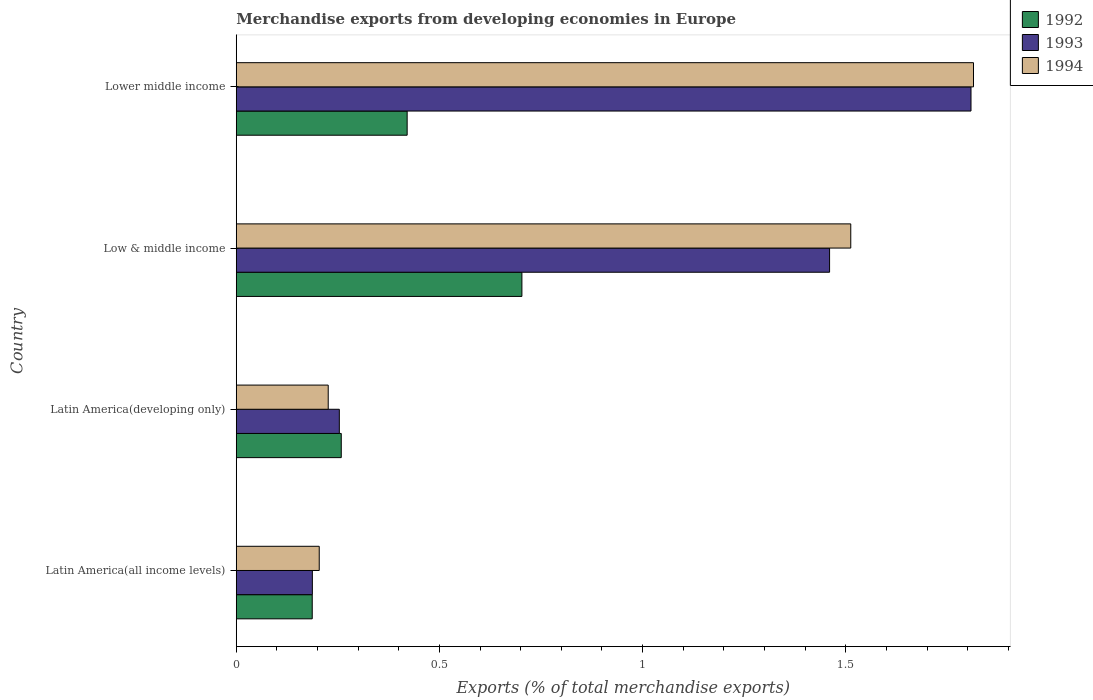How many different coloured bars are there?
Your response must be concise. 3. Are the number of bars per tick equal to the number of legend labels?
Offer a very short reply. Yes. How many bars are there on the 4th tick from the top?
Offer a terse response. 3. How many bars are there on the 2nd tick from the bottom?
Your response must be concise. 3. What is the label of the 4th group of bars from the top?
Your answer should be compact. Latin America(all income levels). What is the percentage of total merchandise exports in 1994 in Low & middle income?
Give a very brief answer. 1.51. Across all countries, what is the maximum percentage of total merchandise exports in 1993?
Your response must be concise. 1.81. Across all countries, what is the minimum percentage of total merchandise exports in 1994?
Give a very brief answer. 0.2. In which country was the percentage of total merchandise exports in 1994 maximum?
Offer a terse response. Lower middle income. In which country was the percentage of total merchandise exports in 1994 minimum?
Your answer should be very brief. Latin America(all income levels). What is the total percentage of total merchandise exports in 1994 in the graph?
Give a very brief answer. 3.76. What is the difference between the percentage of total merchandise exports in 1994 in Latin America(all income levels) and that in Low & middle income?
Provide a succinct answer. -1.31. What is the difference between the percentage of total merchandise exports in 1993 in Lower middle income and the percentage of total merchandise exports in 1994 in Latin America(all income levels)?
Give a very brief answer. 1.6. What is the average percentage of total merchandise exports in 1992 per country?
Keep it short and to the point. 0.39. What is the difference between the percentage of total merchandise exports in 1993 and percentage of total merchandise exports in 1994 in Lower middle income?
Provide a short and direct response. -0.01. What is the ratio of the percentage of total merchandise exports in 1992 in Low & middle income to that in Lower middle income?
Provide a succinct answer. 1.67. Is the difference between the percentage of total merchandise exports in 1993 in Low & middle income and Lower middle income greater than the difference between the percentage of total merchandise exports in 1994 in Low & middle income and Lower middle income?
Make the answer very short. No. What is the difference between the highest and the second highest percentage of total merchandise exports in 1994?
Make the answer very short. 0.3. What is the difference between the highest and the lowest percentage of total merchandise exports in 1993?
Give a very brief answer. 1.62. In how many countries, is the percentage of total merchandise exports in 1994 greater than the average percentage of total merchandise exports in 1994 taken over all countries?
Provide a short and direct response. 2. How many bars are there?
Give a very brief answer. 12. Are all the bars in the graph horizontal?
Provide a succinct answer. Yes. How many countries are there in the graph?
Offer a terse response. 4. Are the values on the major ticks of X-axis written in scientific E-notation?
Keep it short and to the point. No. Does the graph contain any zero values?
Ensure brevity in your answer.  No. How many legend labels are there?
Offer a very short reply. 3. What is the title of the graph?
Your answer should be compact. Merchandise exports from developing economies in Europe. What is the label or title of the X-axis?
Ensure brevity in your answer.  Exports (% of total merchandise exports). What is the label or title of the Y-axis?
Give a very brief answer. Country. What is the Exports (% of total merchandise exports) in 1992 in Latin America(all income levels)?
Offer a very short reply. 0.19. What is the Exports (% of total merchandise exports) in 1993 in Latin America(all income levels)?
Offer a very short reply. 0.19. What is the Exports (% of total merchandise exports) in 1994 in Latin America(all income levels)?
Make the answer very short. 0.2. What is the Exports (% of total merchandise exports) of 1992 in Latin America(developing only)?
Your answer should be compact. 0.26. What is the Exports (% of total merchandise exports) in 1993 in Latin America(developing only)?
Your answer should be very brief. 0.25. What is the Exports (% of total merchandise exports) in 1994 in Latin America(developing only)?
Provide a short and direct response. 0.23. What is the Exports (% of total merchandise exports) in 1992 in Low & middle income?
Your answer should be very brief. 0.7. What is the Exports (% of total merchandise exports) in 1993 in Low & middle income?
Offer a terse response. 1.46. What is the Exports (% of total merchandise exports) of 1994 in Low & middle income?
Offer a very short reply. 1.51. What is the Exports (% of total merchandise exports) of 1992 in Lower middle income?
Your answer should be compact. 0.42. What is the Exports (% of total merchandise exports) in 1993 in Lower middle income?
Your response must be concise. 1.81. What is the Exports (% of total merchandise exports) in 1994 in Lower middle income?
Make the answer very short. 1.81. Across all countries, what is the maximum Exports (% of total merchandise exports) of 1992?
Provide a short and direct response. 0.7. Across all countries, what is the maximum Exports (% of total merchandise exports) in 1993?
Offer a very short reply. 1.81. Across all countries, what is the maximum Exports (% of total merchandise exports) in 1994?
Your answer should be very brief. 1.81. Across all countries, what is the minimum Exports (% of total merchandise exports) in 1992?
Provide a short and direct response. 0.19. Across all countries, what is the minimum Exports (% of total merchandise exports) in 1993?
Offer a very short reply. 0.19. Across all countries, what is the minimum Exports (% of total merchandise exports) of 1994?
Give a very brief answer. 0.2. What is the total Exports (% of total merchandise exports) in 1992 in the graph?
Your response must be concise. 1.57. What is the total Exports (% of total merchandise exports) of 1993 in the graph?
Offer a very short reply. 3.71. What is the total Exports (% of total merchandise exports) of 1994 in the graph?
Offer a very short reply. 3.76. What is the difference between the Exports (% of total merchandise exports) in 1992 in Latin America(all income levels) and that in Latin America(developing only)?
Make the answer very short. -0.07. What is the difference between the Exports (% of total merchandise exports) of 1993 in Latin America(all income levels) and that in Latin America(developing only)?
Give a very brief answer. -0.07. What is the difference between the Exports (% of total merchandise exports) in 1994 in Latin America(all income levels) and that in Latin America(developing only)?
Make the answer very short. -0.02. What is the difference between the Exports (% of total merchandise exports) in 1992 in Latin America(all income levels) and that in Low & middle income?
Give a very brief answer. -0.52. What is the difference between the Exports (% of total merchandise exports) of 1993 in Latin America(all income levels) and that in Low & middle income?
Your response must be concise. -1.27. What is the difference between the Exports (% of total merchandise exports) of 1994 in Latin America(all income levels) and that in Low & middle income?
Ensure brevity in your answer.  -1.31. What is the difference between the Exports (% of total merchandise exports) of 1992 in Latin America(all income levels) and that in Lower middle income?
Give a very brief answer. -0.23. What is the difference between the Exports (% of total merchandise exports) of 1993 in Latin America(all income levels) and that in Lower middle income?
Ensure brevity in your answer.  -1.62. What is the difference between the Exports (% of total merchandise exports) of 1994 in Latin America(all income levels) and that in Lower middle income?
Offer a terse response. -1.61. What is the difference between the Exports (% of total merchandise exports) of 1992 in Latin America(developing only) and that in Low & middle income?
Make the answer very short. -0.44. What is the difference between the Exports (% of total merchandise exports) of 1993 in Latin America(developing only) and that in Low & middle income?
Offer a terse response. -1.21. What is the difference between the Exports (% of total merchandise exports) in 1994 in Latin America(developing only) and that in Low & middle income?
Your response must be concise. -1.29. What is the difference between the Exports (% of total merchandise exports) in 1992 in Latin America(developing only) and that in Lower middle income?
Make the answer very short. -0.16. What is the difference between the Exports (% of total merchandise exports) in 1993 in Latin America(developing only) and that in Lower middle income?
Provide a short and direct response. -1.55. What is the difference between the Exports (% of total merchandise exports) in 1994 in Latin America(developing only) and that in Lower middle income?
Your response must be concise. -1.59. What is the difference between the Exports (% of total merchandise exports) in 1992 in Low & middle income and that in Lower middle income?
Keep it short and to the point. 0.28. What is the difference between the Exports (% of total merchandise exports) of 1993 in Low & middle income and that in Lower middle income?
Your answer should be very brief. -0.35. What is the difference between the Exports (% of total merchandise exports) of 1994 in Low & middle income and that in Lower middle income?
Provide a succinct answer. -0.3. What is the difference between the Exports (% of total merchandise exports) in 1992 in Latin America(all income levels) and the Exports (% of total merchandise exports) in 1993 in Latin America(developing only)?
Ensure brevity in your answer.  -0.07. What is the difference between the Exports (% of total merchandise exports) of 1992 in Latin America(all income levels) and the Exports (% of total merchandise exports) of 1994 in Latin America(developing only)?
Provide a short and direct response. -0.04. What is the difference between the Exports (% of total merchandise exports) of 1993 in Latin America(all income levels) and the Exports (% of total merchandise exports) of 1994 in Latin America(developing only)?
Keep it short and to the point. -0.04. What is the difference between the Exports (% of total merchandise exports) of 1992 in Latin America(all income levels) and the Exports (% of total merchandise exports) of 1993 in Low & middle income?
Your response must be concise. -1.27. What is the difference between the Exports (% of total merchandise exports) in 1992 in Latin America(all income levels) and the Exports (% of total merchandise exports) in 1994 in Low & middle income?
Your answer should be very brief. -1.33. What is the difference between the Exports (% of total merchandise exports) in 1993 in Latin America(all income levels) and the Exports (% of total merchandise exports) in 1994 in Low & middle income?
Your answer should be compact. -1.32. What is the difference between the Exports (% of total merchandise exports) in 1992 in Latin America(all income levels) and the Exports (% of total merchandise exports) in 1993 in Lower middle income?
Offer a terse response. -1.62. What is the difference between the Exports (% of total merchandise exports) in 1992 in Latin America(all income levels) and the Exports (% of total merchandise exports) in 1994 in Lower middle income?
Provide a short and direct response. -1.63. What is the difference between the Exports (% of total merchandise exports) of 1993 in Latin America(all income levels) and the Exports (% of total merchandise exports) of 1994 in Lower middle income?
Make the answer very short. -1.63. What is the difference between the Exports (% of total merchandise exports) of 1992 in Latin America(developing only) and the Exports (% of total merchandise exports) of 1993 in Low & middle income?
Offer a terse response. -1.2. What is the difference between the Exports (% of total merchandise exports) in 1992 in Latin America(developing only) and the Exports (% of total merchandise exports) in 1994 in Low & middle income?
Your answer should be very brief. -1.25. What is the difference between the Exports (% of total merchandise exports) of 1993 in Latin America(developing only) and the Exports (% of total merchandise exports) of 1994 in Low & middle income?
Offer a terse response. -1.26. What is the difference between the Exports (% of total merchandise exports) in 1992 in Latin America(developing only) and the Exports (% of total merchandise exports) in 1993 in Lower middle income?
Give a very brief answer. -1.55. What is the difference between the Exports (% of total merchandise exports) in 1992 in Latin America(developing only) and the Exports (% of total merchandise exports) in 1994 in Lower middle income?
Keep it short and to the point. -1.56. What is the difference between the Exports (% of total merchandise exports) in 1993 in Latin America(developing only) and the Exports (% of total merchandise exports) in 1994 in Lower middle income?
Your answer should be compact. -1.56. What is the difference between the Exports (% of total merchandise exports) in 1992 in Low & middle income and the Exports (% of total merchandise exports) in 1993 in Lower middle income?
Provide a short and direct response. -1.11. What is the difference between the Exports (% of total merchandise exports) in 1992 in Low & middle income and the Exports (% of total merchandise exports) in 1994 in Lower middle income?
Offer a very short reply. -1.11. What is the difference between the Exports (% of total merchandise exports) in 1993 in Low & middle income and the Exports (% of total merchandise exports) in 1994 in Lower middle income?
Provide a succinct answer. -0.35. What is the average Exports (% of total merchandise exports) in 1992 per country?
Offer a terse response. 0.39. What is the average Exports (% of total merchandise exports) of 1993 per country?
Your answer should be very brief. 0.93. What is the average Exports (% of total merchandise exports) in 1994 per country?
Give a very brief answer. 0.94. What is the difference between the Exports (% of total merchandise exports) of 1992 and Exports (% of total merchandise exports) of 1993 in Latin America(all income levels)?
Offer a terse response. -0. What is the difference between the Exports (% of total merchandise exports) in 1992 and Exports (% of total merchandise exports) in 1994 in Latin America(all income levels)?
Offer a terse response. -0.02. What is the difference between the Exports (% of total merchandise exports) in 1993 and Exports (% of total merchandise exports) in 1994 in Latin America(all income levels)?
Give a very brief answer. -0.02. What is the difference between the Exports (% of total merchandise exports) in 1992 and Exports (% of total merchandise exports) in 1993 in Latin America(developing only)?
Ensure brevity in your answer.  0. What is the difference between the Exports (% of total merchandise exports) in 1992 and Exports (% of total merchandise exports) in 1994 in Latin America(developing only)?
Make the answer very short. 0.03. What is the difference between the Exports (% of total merchandise exports) in 1993 and Exports (% of total merchandise exports) in 1994 in Latin America(developing only)?
Offer a terse response. 0.03. What is the difference between the Exports (% of total merchandise exports) of 1992 and Exports (% of total merchandise exports) of 1993 in Low & middle income?
Provide a succinct answer. -0.76. What is the difference between the Exports (% of total merchandise exports) of 1992 and Exports (% of total merchandise exports) of 1994 in Low & middle income?
Provide a short and direct response. -0.81. What is the difference between the Exports (% of total merchandise exports) in 1993 and Exports (% of total merchandise exports) in 1994 in Low & middle income?
Provide a short and direct response. -0.05. What is the difference between the Exports (% of total merchandise exports) in 1992 and Exports (% of total merchandise exports) in 1993 in Lower middle income?
Your answer should be very brief. -1.39. What is the difference between the Exports (% of total merchandise exports) in 1992 and Exports (% of total merchandise exports) in 1994 in Lower middle income?
Keep it short and to the point. -1.39. What is the difference between the Exports (% of total merchandise exports) of 1993 and Exports (% of total merchandise exports) of 1994 in Lower middle income?
Your response must be concise. -0.01. What is the ratio of the Exports (% of total merchandise exports) in 1992 in Latin America(all income levels) to that in Latin America(developing only)?
Provide a succinct answer. 0.72. What is the ratio of the Exports (% of total merchandise exports) in 1993 in Latin America(all income levels) to that in Latin America(developing only)?
Keep it short and to the point. 0.74. What is the ratio of the Exports (% of total merchandise exports) in 1994 in Latin America(all income levels) to that in Latin America(developing only)?
Make the answer very short. 0.9. What is the ratio of the Exports (% of total merchandise exports) in 1992 in Latin America(all income levels) to that in Low & middle income?
Your answer should be very brief. 0.27. What is the ratio of the Exports (% of total merchandise exports) of 1993 in Latin America(all income levels) to that in Low & middle income?
Provide a short and direct response. 0.13. What is the ratio of the Exports (% of total merchandise exports) in 1994 in Latin America(all income levels) to that in Low & middle income?
Provide a succinct answer. 0.14. What is the ratio of the Exports (% of total merchandise exports) of 1992 in Latin America(all income levels) to that in Lower middle income?
Provide a short and direct response. 0.44. What is the ratio of the Exports (% of total merchandise exports) in 1993 in Latin America(all income levels) to that in Lower middle income?
Ensure brevity in your answer.  0.1. What is the ratio of the Exports (% of total merchandise exports) in 1994 in Latin America(all income levels) to that in Lower middle income?
Give a very brief answer. 0.11. What is the ratio of the Exports (% of total merchandise exports) in 1992 in Latin America(developing only) to that in Low & middle income?
Provide a short and direct response. 0.37. What is the ratio of the Exports (% of total merchandise exports) in 1993 in Latin America(developing only) to that in Low & middle income?
Keep it short and to the point. 0.17. What is the ratio of the Exports (% of total merchandise exports) of 1994 in Latin America(developing only) to that in Low & middle income?
Ensure brevity in your answer.  0.15. What is the ratio of the Exports (% of total merchandise exports) in 1992 in Latin America(developing only) to that in Lower middle income?
Make the answer very short. 0.61. What is the ratio of the Exports (% of total merchandise exports) in 1993 in Latin America(developing only) to that in Lower middle income?
Offer a terse response. 0.14. What is the ratio of the Exports (% of total merchandise exports) of 1994 in Latin America(developing only) to that in Lower middle income?
Provide a short and direct response. 0.12. What is the ratio of the Exports (% of total merchandise exports) in 1992 in Low & middle income to that in Lower middle income?
Keep it short and to the point. 1.67. What is the ratio of the Exports (% of total merchandise exports) of 1993 in Low & middle income to that in Lower middle income?
Ensure brevity in your answer.  0.81. What is the ratio of the Exports (% of total merchandise exports) in 1994 in Low & middle income to that in Lower middle income?
Your answer should be very brief. 0.83. What is the difference between the highest and the second highest Exports (% of total merchandise exports) of 1992?
Ensure brevity in your answer.  0.28. What is the difference between the highest and the second highest Exports (% of total merchandise exports) in 1993?
Make the answer very short. 0.35. What is the difference between the highest and the second highest Exports (% of total merchandise exports) of 1994?
Your response must be concise. 0.3. What is the difference between the highest and the lowest Exports (% of total merchandise exports) in 1992?
Your answer should be very brief. 0.52. What is the difference between the highest and the lowest Exports (% of total merchandise exports) of 1993?
Provide a short and direct response. 1.62. What is the difference between the highest and the lowest Exports (% of total merchandise exports) of 1994?
Ensure brevity in your answer.  1.61. 